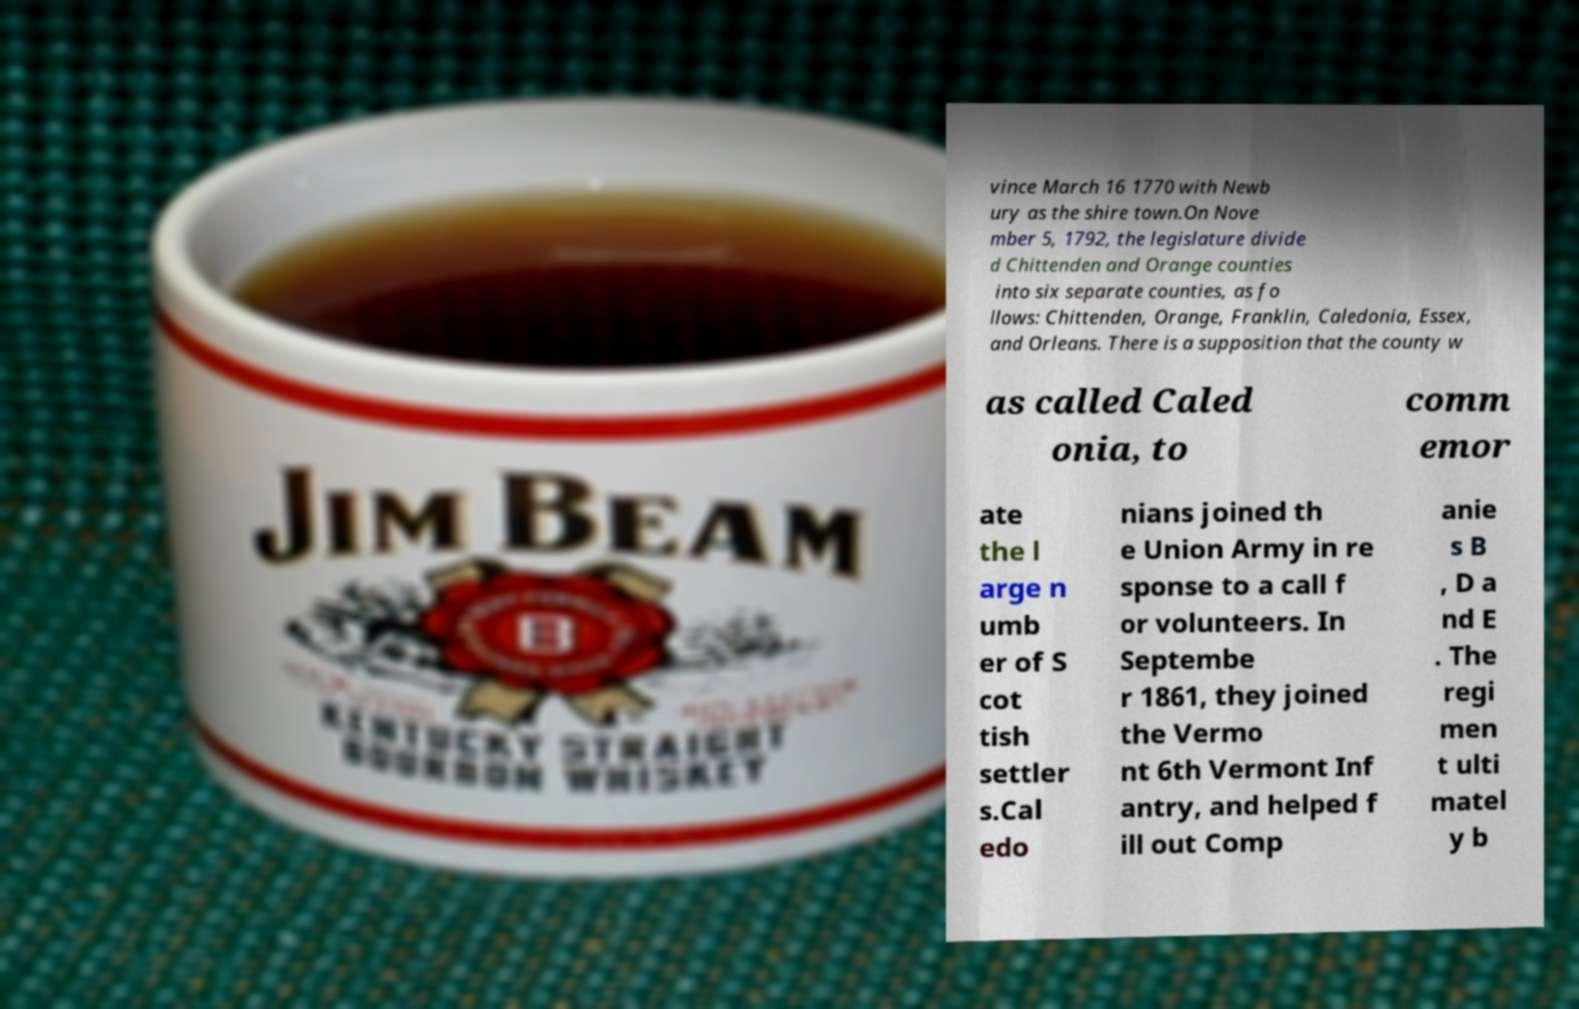Please identify and transcribe the text found in this image. vince March 16 1770 with Newb ury as the shire town.On Nove mber 5, 1792, the legislature divide d Chittenden and Orange counties into six separate counties, as fo llows: Chittenden, Orange, Franklin, Caledonia, Essex, and Orleans. There is a supposition that the county w as called Caled onia, to comm emor ate the l arge n umb er of S cot tish settler s.Cal edo nians joined th e Union Army in re sponse to a call f or volunteers. In Septembe r 1861, they joined the Vermo nt 6th Vermont Inf antry, and helped f ill out Comp anie s B , D a nd E . The regi men t ulti matel y b 